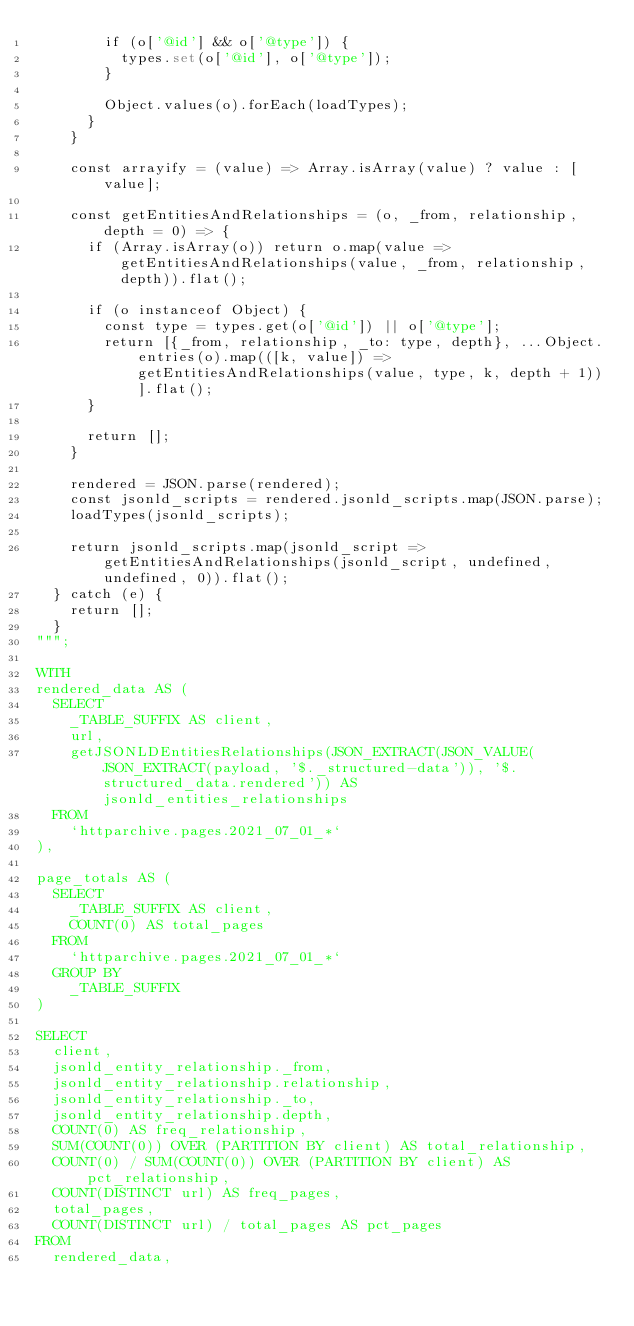<code> <loc_0><loc_0><loc_500><loc_500><_SQL_>        if (o['@id'] && o['@type']) {
          types.set(o['@id'], o['@type']);
        }

        Object.values(o).forEach(loadTypes);
      }
    }

    const arrayify = (value) => Array.isArray(value) ? value : [value];

    const getEntitiesAndRelationships = (o, _from, relationship, depth = 0) => {
      if (Array.isArray(o)) return o.map(value => getEntitiesAndRelationships(value, _from, relationship, depth)).flat();

      if (o instanceof Object) {
        const type = types.get(o['@id']) || o['@type'];
        return [{_from, relationship, _to: type, depth}, ...Object.entries(o).map(([k, value]) => getEntitiesAndRelationships(value, type, k, depth + 1))].flat();
      }

      return [];
    }

    rendered = JSON.parse(rendered);
    const jsonld_scripts = rendered.jsonld_scripts.map(JSON.parse);
    loadTypes(jsonld_scripts);

    return jsonld_scripts.map(jsonld_script => getEntitiesAndRelationships(jsonld_script, undefined, undefined, 0)).flat();
  } catch (e) {
    return [];
  }
""";

WITH
rendered_data AS (
  SELECT
    _TABLE_SUFFIX AS client,
    url,
    getJSONLDEntitiesRelationships(JSON_EXTRACT(JSON_VALUE(JSON_EXTRACT(payload, '$._structured-data')), '$.structured_data.rendered')) AS jsonld_entities_relationships
  FROM
    `httparchive.pages.2021_07_01_*`
),

page_totals AS (
  SELECT
    _TABLE_SUFFIX AS client,
    COUNT(0) AS total_pages
  FROM
    `httparchive.pages.2021_07_01_*`
  GROUP BY
    _TABLE_SUFFIX
)

SELECT
  client,
  jsonld_entity_relationship._from,
  jsonld_entity_relationship.relationship,
  jsonld_entity_relationship._to,
  jsonld_entity_relationship.depth,
  COUNT(0) AS freq_relationship,
  SUM(COUNT(0)) OVER (PARTITION BY client) AS total_relationship,
  COUNT(0) / SUM(COUNT(0)) OVER (PARTITION BY client) AS pct_relationship,
  COUNT(DISTINCT url) AS freq_pages,
  total_pages,
  COUNT(DISTINCT url) / total_pages AS pct_pages
FROM
  rendered_data,</code> 